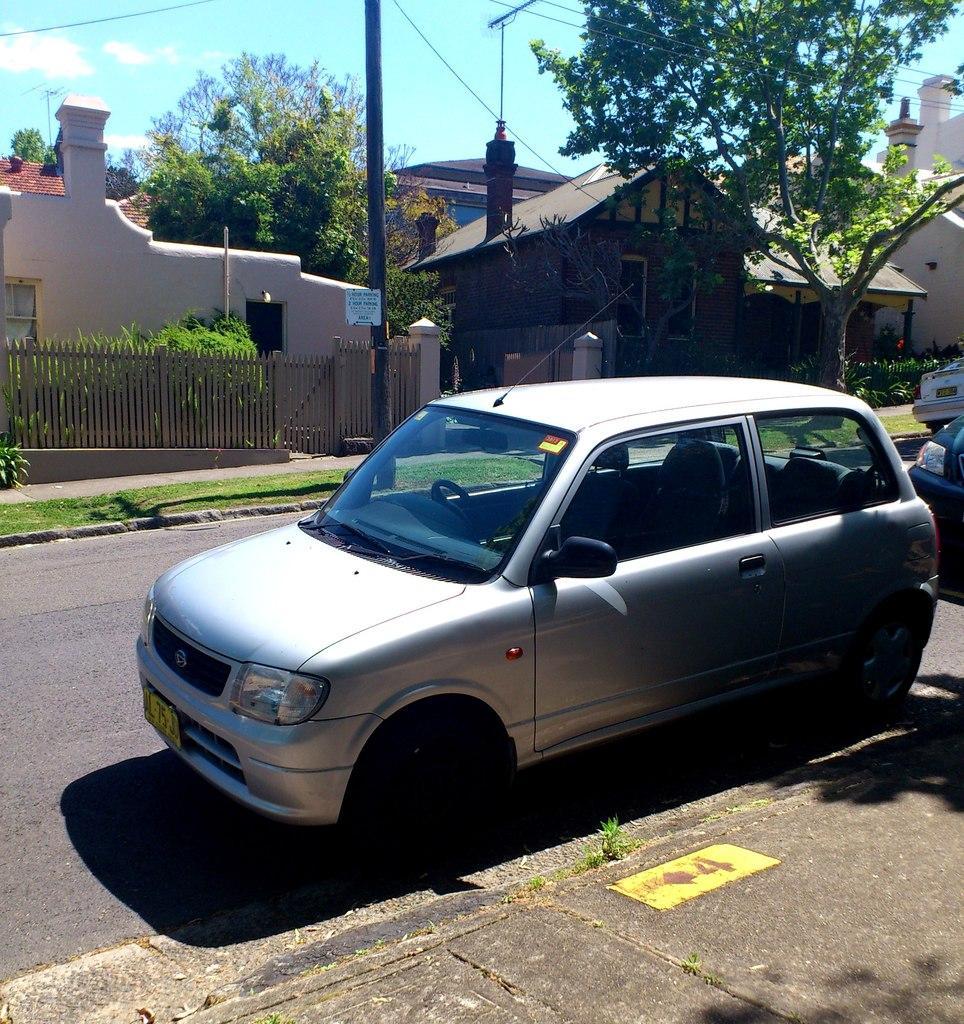How would you summarize this image in a sentence or two? This image is taken outdoors. At the bottom of the image there is a road and a floor. In the middle of the image there is a car parked on the road. At the top of the image there is a sky with clouds. In the background there are a few houses, trees and a railing. On the right side of the image two vehicles are parked on the road. 